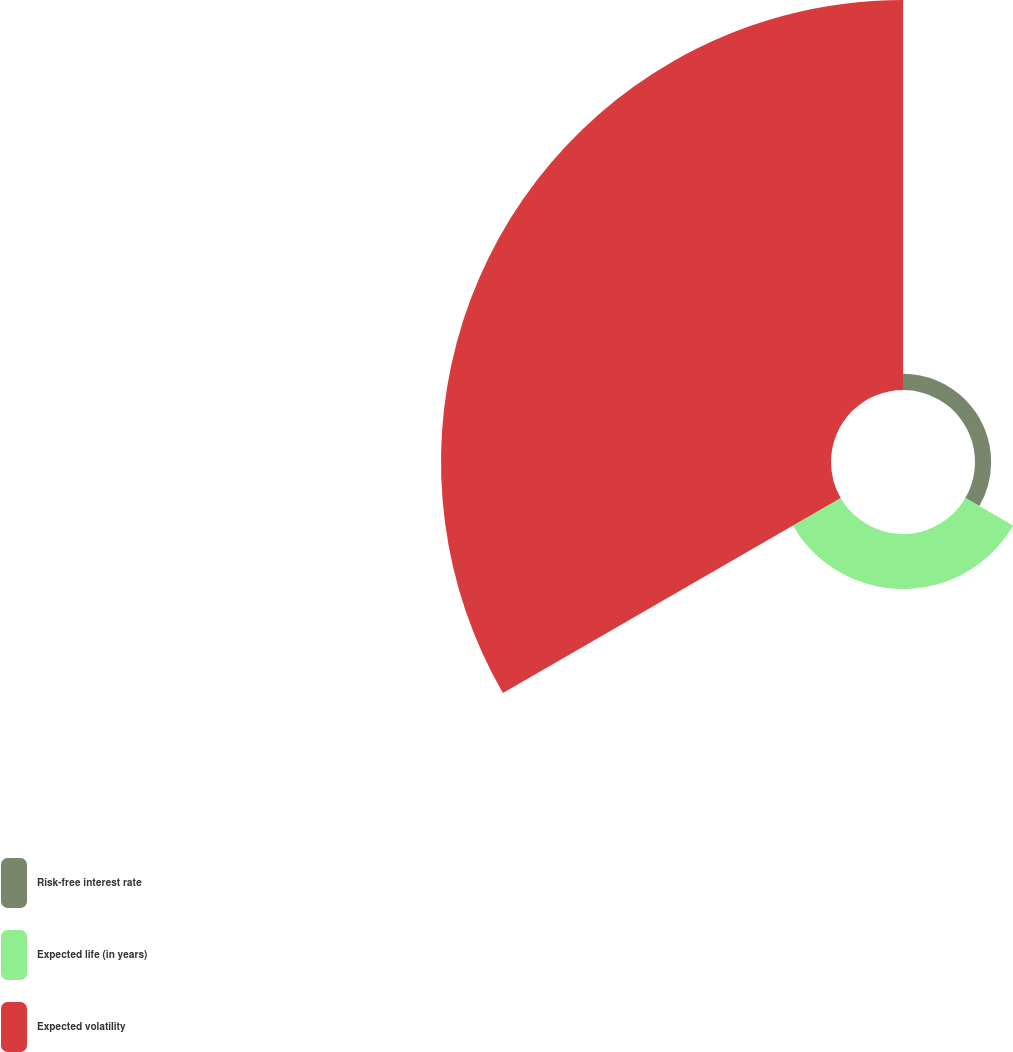Convert chart. <chart><loc_0><loc_0><loc_500><loc_500><pie_chart><fcel>Risk-free interest rate<fcel>Expected life (in years)<fcel>Expected volatility<nl><fcel>3.5%<fcel>11.95%<fcel>84.55%<nl></chart> 